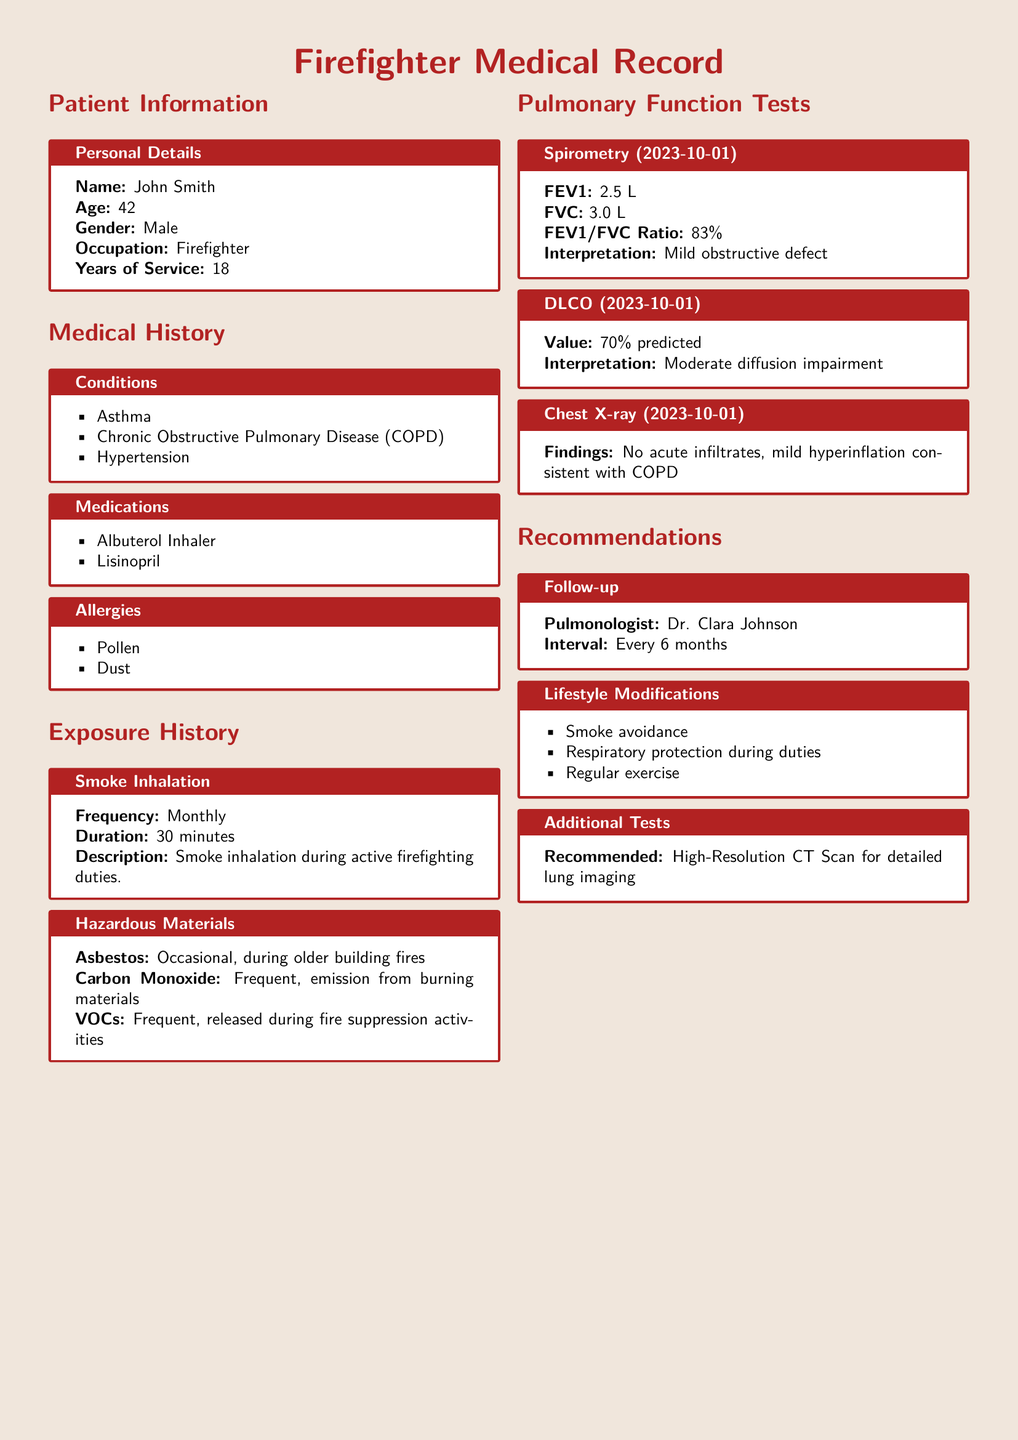What is the patient's age? The patient's age is specifically listed in the personal details of the document.
Answer: 42 What medications is the patient taking? The medications are detailed in the medical history section of the document.
Answer: Albuterol Inhaler, Lisinopril How often does the patient experience smoke inhalation? The frequency of smoke inhalation is mentioned in the exposure history section.
Answer: Monthly What is the FEV1 value from the Spirometry test? The FEV1 value is indicated in the pulmonary function tests section of the document.
Answer: 2.5 L What is the patient's interpretation of the DLCO test? The interpretation of the DLCO test is provided in the pulmonary function tests section.
Answer: Moderate diffusion impairment How frequently is the patient recommended to see the pulmonologist? The follow-up interval with the pulmonologist is mentioned in the recommendations section.
Answer: Every 6 months What lifestyle modification is suggested concerning smoke? The lifestyle modifications provide suggestions to avoid smoke.
Answer: Smoke avoidance What additional test is recommended for the patient? The recommendations section lists the additional tests suggested for a detailed evaluation.
Answer: High-Resolution CT Scan for detailed lung imaging What type of work does the patient do? The occupation of the patient is clearly mentioned in the personal details section.
Answer: Firefighter 